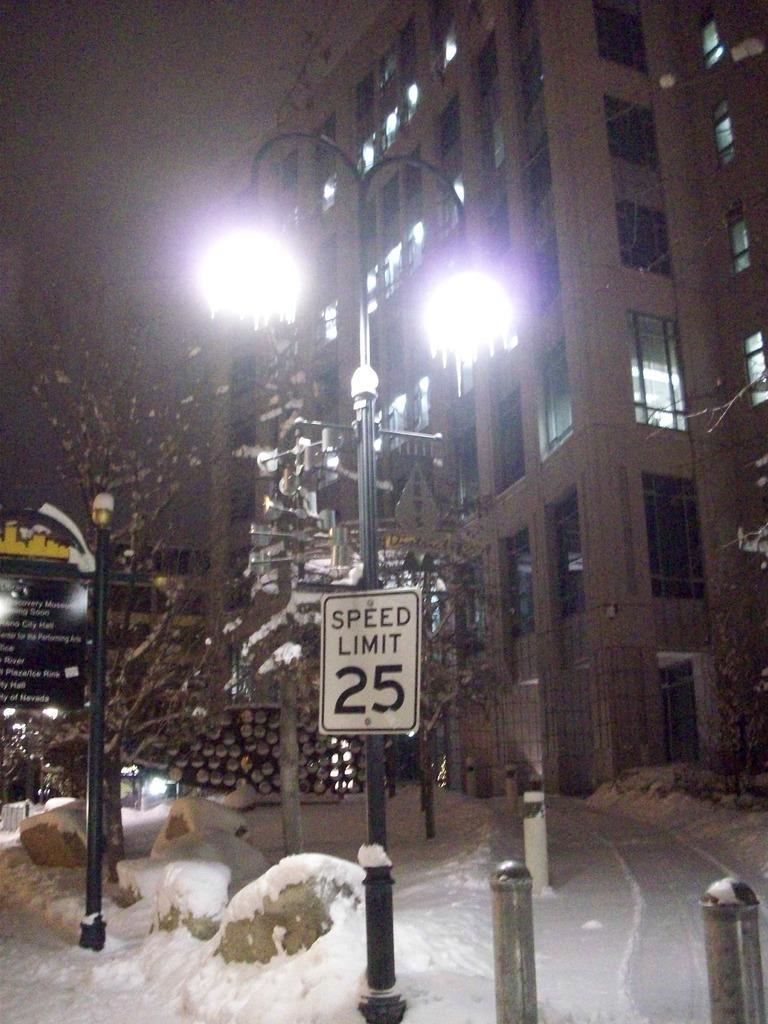Can you describe this image briefly? In this picture we can see few poles, sign boards, buildings and trees, and also we can see few metal rods and snow. 